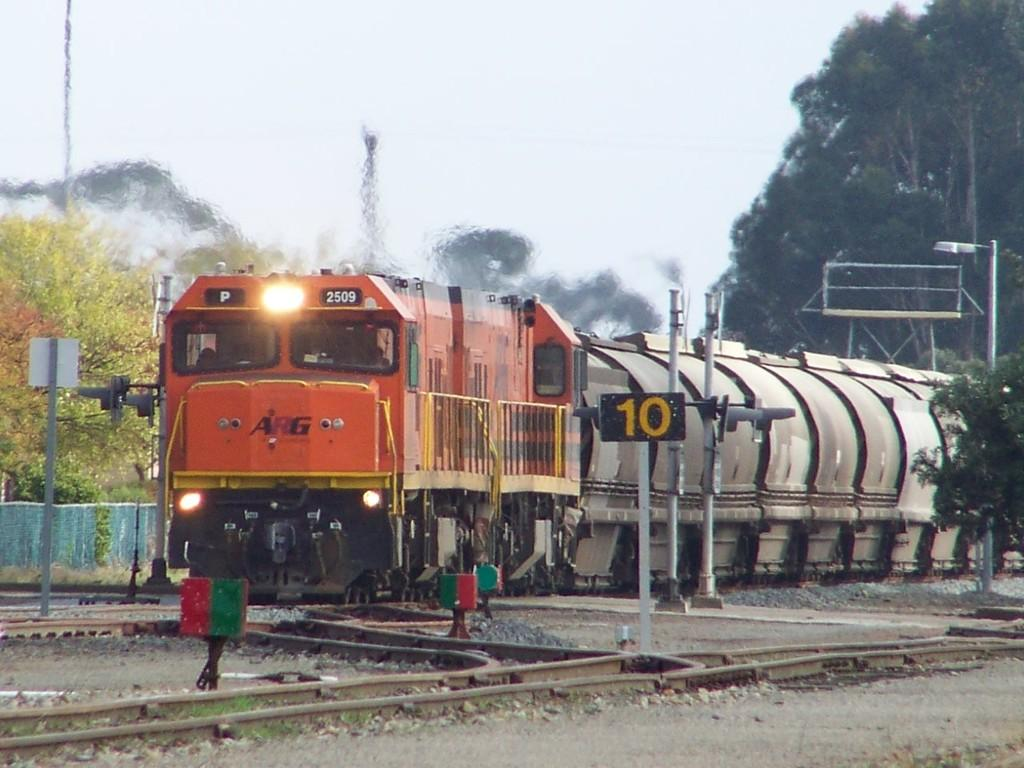What can be seen in the sky in the image? The sky is visible in the image. What type of natural vegetation is present in the image? There are trees in the image. What mode of transportation is featured in the image? There is a train in the image. What type of illumination is present in the image? There are lights in the image. What type of structures are present in the image? There are poles and a wall in the image. What type of surface is present in the image? Train tracks are present in the image. What type of terrain is visible in the image? Stones are visible in the image. Can you describe any unspecified objects in the image? There are a few unspecified objects in the image. What letters are being taught in the image? There is no indication of any teaching or letters present in the image. How is the string used in the image? There is no string present in the image. 